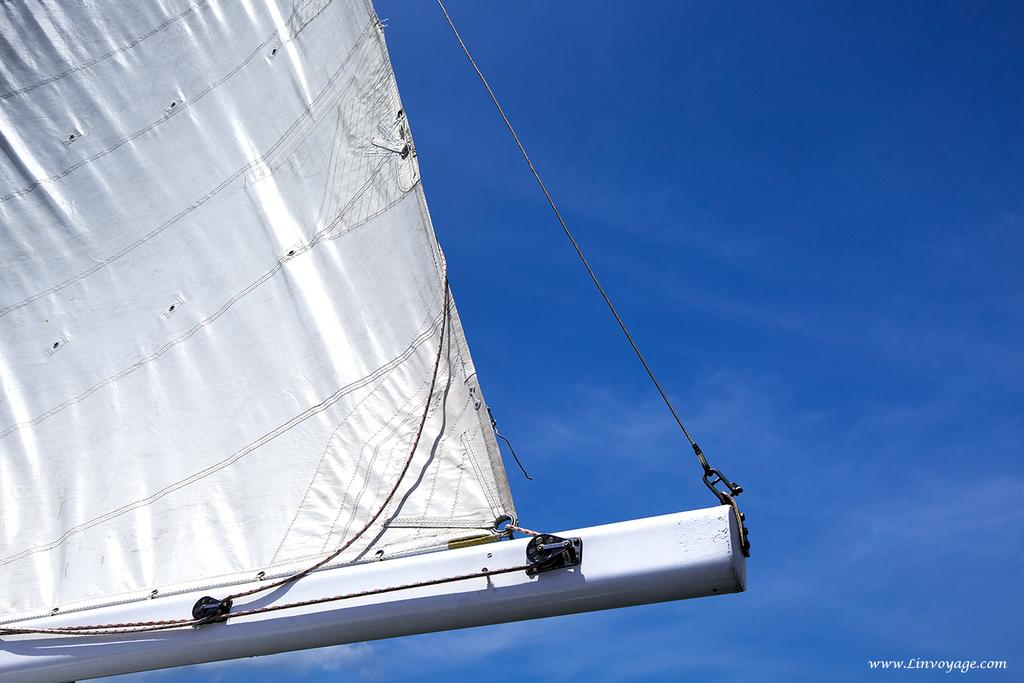What type of metal object is present in the image? There is a metal object in the image, but the specific type is not mentioned. What other items can be seen in the image? There are ropes and hooks in the image. What is the color of the banner in the image? The banner in the image is white. What can be seen in the background of the image? The sky with clouds is visible in the background of the image. What type of peace symbol can be seen on the metal object in the image? There is no peace symbol present on the metal object in the image. What type of attraction is being advertised on the white banner in the image? There is no attraction mentioned on the white banner in the image. 